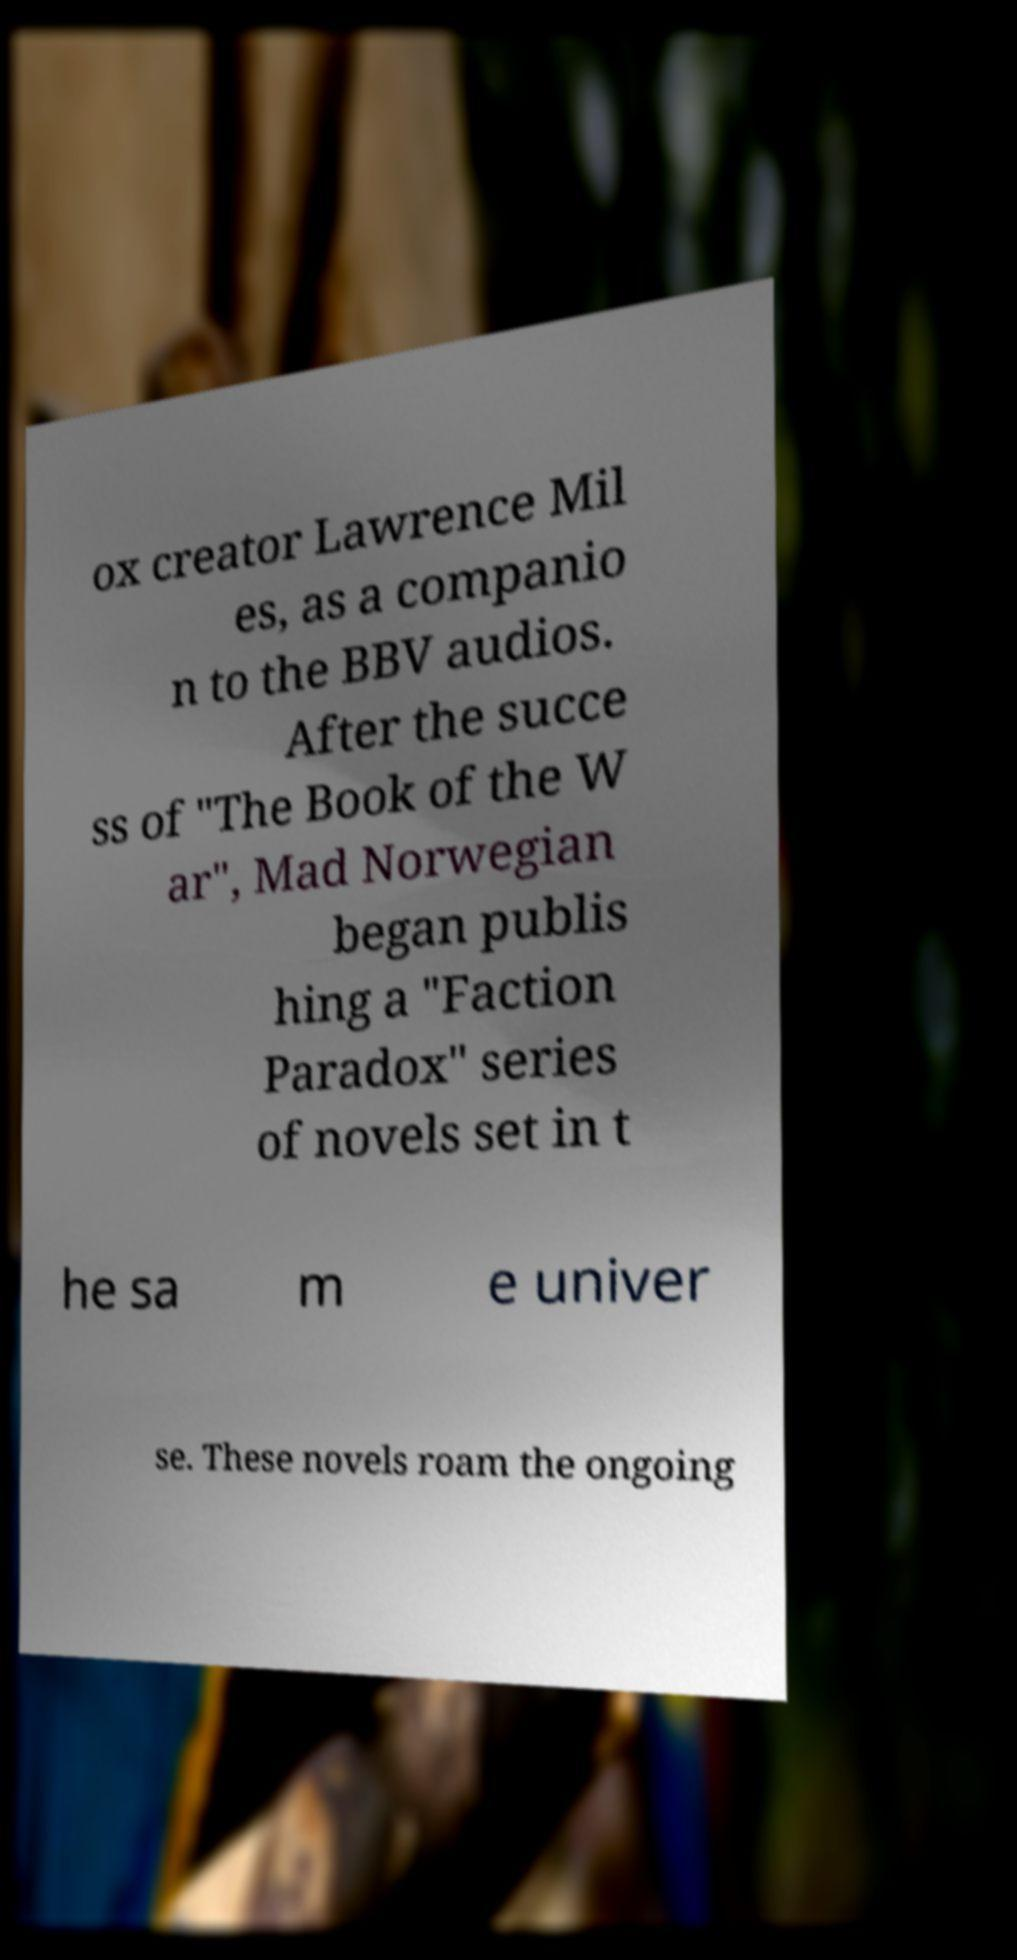For documentation purposes, I need the text within this image transcribed. Could you provide that? ox creator Lawrence Mil es, as a companio n to the BBV audios. After the succe ss of "The Book of the W ar", Mad Norwegian began publis hing a "Faction Paradox" series of novels set in t he sa m e univer se. These novels roam the ongoing 